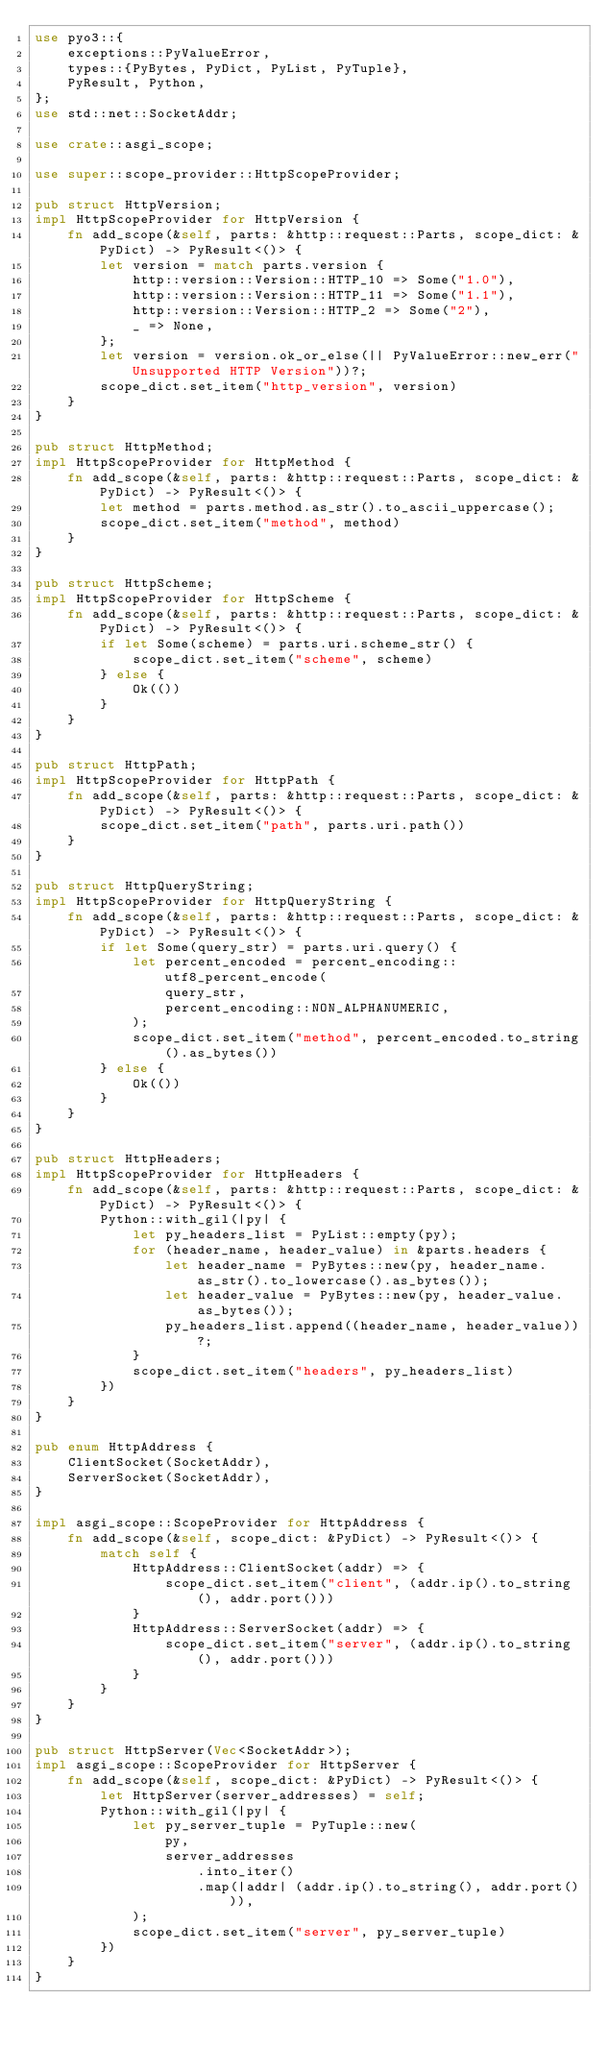<code> <loc_0><loc_0><loc_500><loc_500><_Rust_>use pyo3::{
    exceptions::PyValueError,
    types::{PyBytes, PyDict, PyList, PyTuple},
    PyResult, Python,
};
use std::net::SocketAddr;

use crate::asgi_scope;

use super::scope_provider::HttpScopeProvider;

pub struct HttpVersion;
impl HttpScopeProvider for HttpVersion {
    fn add_scope(&self, parts: &http::request::Parts, scope_dict: &PyDict) -> PyResult<()> {
        let version = match parts.version {
            http::version::Version::HTTP_10 => Some("1.0"),
            http::version::Version::HTTP_11 => Some("1.1"),
            http::version::Version::HTTP_2 => Some("2"),
            _ => None,
        };
        let version = version.ok_or_else(|| PyValueError::new_err("Unsupported HTTP Version"))?;
        scope_dict.set_item("http_version", version)
    }
}

pub struct HttpMethod;
impl HttpScopeProvider for HttpMethod {
    fn add_scope(&self, parts: &http::request::Parts, scope_dict: &PyDict) -> PyResult<()> {
        let method = parts.method.as_str().to_ascii_uppercase();
        scope_dict.set_item("method", method)
    }
}

pub struct HttpScheme;
impl HttpScopeProvider for HttpScheme {
    fn add_scope(&self, parts: &http::request::Parts, scope_dict: &PyDict) -> PyResult<()> {
        if let Some(scheme) = parts.uri.scheme_str() {
            scope_dict.set_item("scheme", scheme)
        } else {
            Ok(())
        }
    }
}

pub struct HttpPath;
impl HttpScopeProvider for HttpPath {
    fn add_scope(&self, parts: &http::request::Parts, scope_dict: &PyDict) -> PyResult<()> {
        scope_dict.set_item("path", parts.uri.path())
    }
}

pub struct HttpQueryString;
impl HttpScopeProvider for HttpQueryString {
    fn add_scope(&self, parts: &http::request::Parts, scope_dict: &PyDict) -> PyResult<()> {
        if let Some(query_str) = parts.uri.query() {
            let percent_encoded = percent_encoding::utf8_percent_encode(
                query_str,
                percent_encoding::NON_ALPHANUMERIC,
            );
            scope_dict.set_item("method", percent_encoded.to_string().as_bytes())
        } else {
            Ok(())
        }
    }
}

pub struct HttpHeaders;
impl HttpScopeProvider for HttpHeaders {
    fn add_scope(&self, parts: &http::request::Parts, scope_dict: &PyDict) -> PyResult<()> {
        Python::with_gil(|py| {
            let py_headers_list = PyList::empty(py);
            for (header_name, header_value) in &parts.headers {
                let header_name = PyBytes::new(py, header_name.as_str().to_lowercase().as_bytes());
                let header_value = PyBytes::new(py, header_value.as_bytes());
                py_headers_list.append((header_name, header_value))?;
            }
            scope_dict.set_item("headers", py_headers_list)
        })
    }
}

pub enum HttpAddress {
    ClientSocket(SocketAddr),
    ServerSocket(SocketAddr),
}

impl asgi_scope::ScopeProvider for HttpAddress {
    fn add_scope(&self, scope_dict: &PyDict) -> PyResult<()> {
        match self {
            HttpAddress::ClientSocket(addr) => {
                scope_dict.set_item("client", (addr.ip().to_string(), addr.port()))
            }
            HttpAddress::ServerSocket(addr) => {
                scope_dict.set_item("server", (addr.ip().to_string(), addr.port()))
            }
        }
    }
}

pub struct HttpServer(Vec<SocketAddr>);
impl asgi_scope::ScopeProvider for HttpServer {
    fn add_scope(&self, scope_dict: &PyDict) -> PyResult<()> {
        let HttpServer(server_addresses) = self;
        Python::with_gil(|py| {
            let py_server_tuple = PyTuple::new(
                py,
                server_addresses
                    .into_iter()
                    .map(|addr| (addr.ip().to_string(), addr.port())),
            );
            scope_dict.set_item("server", py_server_tuple)
        })
    }
}
</code> 